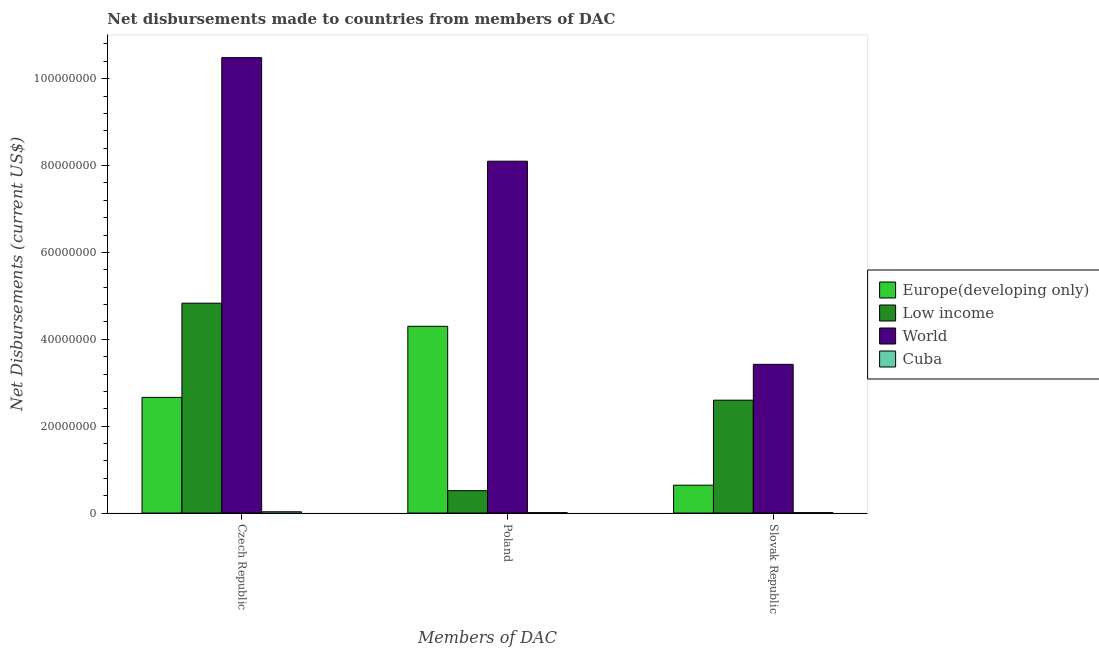How many bars are there on the 1st tick from the right?
Keep it short and to the point. 4. What is the label of the 1st group of bars from the left?
Make the answer very short. Czech Republic. What is the net disbursements made by slovak republic in Low income?
Offer a very short reply. 2.60e+07. Across all countries, what is the maximum net disbursements made by slovak republic?
Ensure brevity in your answer.  3.42e+07. Across all countries, what is the minimum net disbursements made by czech republic?
Offer a terse response. 2.90e+05. In which country was the net disbursements made by czech republic maximum?
Give a very brief answer. World. In which country was the net disbursements made by slovak republic minimum?
Your answer should be very brief. Cuba. What is the total net disbursements made by poland in the graph?
Keep it short and to the point. 1.29e+08. What is the difference between the net disbursements made by slovak republic in Europe(developing only) and that in World?
Offer a very short reply. -2.78e+07. What is the difference between the net disbursements made by poland in World and the net disbursements made by slovak republic in Low income?
Provide a succinct answer. 5.50e+07. What is the average net disbursements made by czech republic per country?
Offer a very short reply. 4.50e+07. What is the difference between the net disbursements made by poland and net disbursements made by czech republic in Europe(developing only)?
Make the answer very short. 1.64e+07. In how many countries, is the net disbursements made by poland greater than 56000000 US$?
Make the answer very short. 1. What is the ratio of the net disbursements made by czech republic in Low income to that in Cuba?
Keep it short and to the point. 166.59. What is the difference between the highest and the second highest net disbursements made by slovak republic?
Your answer should be compact. 8.25e+06. What is the difference between the highest and the lowest net disbursements made by slovak republic?
Make the answer very short. 3.41e+07. In how many countries, is the net disbursements made by poland greater than the average net disbursements made by poland taken over all countries?
Ensure brevity in your answer.  2. Is the sum of the net disbursements made by poland in Europe(developing only) and Low income greater than the maximum net disbursements made by slovak republic across all countries?
Your answer should be very brief. Yes. What does the 1st bar from the left in Poland represents?
Provide a succinct answer. Europe(developing only). What does the 1st bar from the right in Slovak Republic represents?
Your response must be concise. Cuba. How many bars are there?
Your response must be concise. 12. How many countries are there in the graph?
Your response must be concise. 4. Are the values on the major ticks of Y-axis written in scientific E-notation?
Your answer should be very brief. No. Does the graph contain any zero values?
Provide a succinct answer. No. Does the graph contain grids?
Your answer should be very brief. No. What is the title of the graph?
Your answer should be very brief. Net disbursements made to countries from members of DAC. Does "Belize" appear as one of the legend labels in the graph?
Make the answer very short. No. What is the label or title of the X-axis?
Make the answer very short. Members of DAC. What is the label or title of the Y-axis?
Make the answer very short. Net Disbursements (current US$). What is the Net Disbursements (current US$) of Europe(developing only) in Czech Republic?
Provide a succinct answer. 2.66e+07. What is the Net Disbursements (current US$) in Low income in Czech Republic?
Keep it short and to the point. 4.83e+07. What is the Net Disbursements (current US$) in World in Czech Republic?
Offer a terse response. 1.05e+08. What is the Net Disbursements (current US$) in Cuba in Czech Republic?
Your response must be concise. 2.90e+05. What is the Net Disbursements (current US$) of Europe(developing only) in Poland?
Offer a terse response. 4.30e+07. What is the Net Disbursements (current US$) of Low income in Poland?
Your answer should be compact. 5.15e+06. What is the Net Disbursements (current US$) in World in Poland?
Offer a very short reply. 8.10e+07. What is the Net Disbursements (current US$) of Cuba in Poland?
Offer a very short reply. 9.00e+04. What is the Net Disbursements (current US$) in Europe(developing only) in Slovak Republic?
Provide a succinct answer. 6.41e+06. What is the Net Disbursements (current US$) of Low income in Slovak Republic?
Your response must be concise. 2.60e+07. What is the Net Disbursements (current US$) of World in Slovak Republic?
Offer a terse response. 3.42e+07. Across all Members of DAC, what is the maximum Net Disbursements (current US$) of Europe(developing only)?
Provide a short and direct response. 4.30e+07. Across all Members of DAC, what is the maximum Net Disbursements (current US$) of Low income?
Give a very brief answer. 4.83e+07. Across all Members of DAC, what is the maximum Net Disbursements (current US$) in World?
Your response must be concise. 1.05e+08. Across all Members of DAC, what is the minimum Net Disbursements (current US$) in Europe(developing only)?
Provide a succinct answer. 6.41e+06. Across all Members of DAC, what is the minimum Net Disbursements (current US$) in Low income?
Provide a short and direct response. 5.15e+06. Across all Members of DAC, what is the minimum Net Disbursements (current US$) in World?
Ensure brevity in your answer.  3.42e+07. Across all Members of DAC, what is the minimum Net Disbursements (current US$) of Cuba?
Give a very brief answer. 9.00e+04. What is the total Net Disbursements (current US$) in Europe(developing only) in the graph?
Offer a very short reply. 7.60e+07. What is the total Net Disbursements (current US$) of Low income in the graph?
Offer a very short reply. 7.94e+07. What is the total Net Disbursements (current US$) in World in the graph?
Keep it short and to the point. 2.20e+08. What is the difference between the Net Disbursements (current US$) of Europe(developing only) in Czech Republic and that in Poland?
Offer a very short reply. -1.64e+07. What is the difference between the Net Disbursements (current US$) of Low income in Czech Republic and that in Poland?
Ensure brevity in your answer.  4.32e+07. What is the difference between the Net Disbursements (current US$) of World in Czech Republic and that in Poland?
Make the answer very short. 2.38e+07. What is the difference between the Net Disbursements (current US$) in Cuba in Czech Republic and that in Poland?
Your answer should be compact. 2.00e+05. What is the difference between the Net Disbursements (current US$) in Europe(developing only) in Czech Republic and that in Slovak Republic?
Give a very brief answer. 2.02e+07. What is the difference between the Net Disbursements (current US$) of Low income in Czech Republic and that in Slovak Republic?
Ensure brevity in your answer.  2.23e+07. What is the difference between the Net Disbursements (current US$) in World in Czech Republic and that in Slovak Republic?
Your response must be concise. 7.06e+07. What is the difference between the Net Disbursements (current US$) of Europe(developing only) in Poland and that in Slovak Republic?
Offer a very short reply. 3.66e+07. What is the difference between the Net Disbursements (current US$) of Low income in Poland and that in Slovak Republic?
Your answer should be compact. -2.08e+07. What is the difference between the Net Disbursements (current US$) of World in Poland and that in Slovak Republic?
Your answer should be very brief. 4.68e+07. What is the difference between the Net Disbursements (current US$) in Cuba in Poland and that in Slovak Republic?
Offer a terse response. 0. What is the difference between the Net Disbursements (current US$) of Europe(developing only) in Czech Republic and the Net Disbursements (current US$) of Low income in Poland?
Your response must be concise. 2.15e+07. What is the difference between the Net Disbursements (current US$) in Europe(developing only) in Czech Republic and the Net Disbursements (current US$) in World in Poland?
Give a very brief answer. -5.44e+07. What is the difference between the Net Disbursements (current US$) in Europe(developing only) in Czech Republic and the Net Disbursements (current US$) in Cuba in Poland?
Your answer should be compact. 2.65e+07. What is the difference between the Net Disbursements (current US$) of Low income in Czech Republic and the Net Disbursements (current US$) of World in Poland?
Make the answer very short. -3.27e+07. What is the difference between the Net Disbursements (current US$) of Low income in Czech Republic and the Net Disbursements (current US$) of Cuba in Poland?
Ensure brevity in your answer.  4.82e+07. What is the difference between the Net Disbursements (current US$) of World in Czech Republic and the Net Disbursements (current US$) of Cuba in Poland?
Offer a very short reply. 1.05e+08. What is the difference between the Net Disbursements (current US$) of Europe(developing only) in Czech Republic and the Net Disbursements (current US$) of Low income in Slovak Republic?
Ensure brevity in your answer.  6.40e+05. What is the difference between the Net Disbursements (current US$) in Europe(developing only) in Czech Republic and the Net Disbursements (current US$) in World in Slovak Republic?
Provide a succinct answer. -7.61e+06. What is the difference between the Net Disbursements (current US$) of Europe(developing only) in Czech Republic and the Net Disbursements (current US$) of Cuba in Slovak Republic?
Your answer should be very brief. 2.65e+07. What is the difference between the Net Disbursements (current US$) in Low income in Czech Republic and the Net Disbursements (current US$) in World in Slovak Republic?
Your answer should be compact. 1.41e+07. What is the difference between the Net Disbursements (current US$) in Low income in Czech Republic and the Net Disbursements (current US$) in Cuba in Slovak Republic?
Provide a short and direct response. 4.82e+07. What is the difference between the Net Disbursements (current US$) in World in Czech Republic and the Net Disbursements (current US$) in Cuba in Slovak Republic?
Offer a terse response. 1.05e+08. What is the difference between the Net Disbursements (current US$) in Europe(developing only) in Poland and the Net Disbursements (current US$) in Low income in Slovak Republic?
Provide a succinct answer. 1.70e+07. What is the difference between the Net Disbursements (current US$) in Europe(developing only) in Poland and the Net Disbursements (current US$) in World in Slovak Republic?
Provide a succinct answer. 8.76e+06. What is the difference between the Net Disbursements (current US$) of Europe(developing only) in Poland and the Net Disbursements (current US$) of Cuba in Slovak Republic?
Ensure brevity in your answer.  4.29e+07. What is the difference between the Net Disbursements (current US$) in Low income in Poland and the Net Disbursements (current US$) in World in Slovak Republic?
Provide a short and direct response. -2.91e+07. What is the difference between the Net Disbursements (current US$) of Low income in Poland and the Net Disbursements (current US$) of Cuba in Slovak Republic?
Your answer should be very brief. 5.06e+06. What is the difference between the Net Disbursements (current US$) of World in Poland and the Net Disbursements (current US$) of Cuba in Slovak Republic?
Your response must be concise. 8.09e+07. What is the average Net Disbursements (current US$) of Europe(developing only) per Members of DAC?
Give a very brief answer. 2.53e+07. What is the average Net Disbursements (current US$) of Low income per Members of DAC?
Your answer should be compact. 2.65e+07. What is the average Net Disbursements (current US$) in World per Members of DAC?
Make the answer very short. 7.34e+07. What is the average Net Disbursements (current US$) in Cuba per Members of DAC?
Your answer should be very brief. 1.57e+05. What is the difference between the Net Disbursements (current US$) of Europe(developing only) and Net Disbursements (current US$) of Low income in Czech Republic?
Your answer should be very brief. -2.17e+07. What is the difference between the Net Disbursements (current US$) in Europe(developing only) and Net Disbursements (current US$) in World in Czech Republic?
Offer a very short reply. -7.82e+07. What is the difference between the Net Disbursements (current US$) of Europe(developing only) and Net Disbursements (current US$) of Cuba in Czech Republic?
Offer a terse response. 2.63e+07. What is the difference between the Net Disbursements (current US$) in Low income and Net Disbursements (current US$) in World in Czech Republic?
Your answer should be compact. -5.65e+07. What is the difference between the Net Disbursements (current US$) of Low income and Net Disbursements (current US$) of Cuba in Czech Republic?
Offer a very short reply. 4.80e+07. What is the difference between the Net Disbursements (current US$) in World and Net Disbursements (current US$) in Cuba in Czech Republic?
Make the answer very short. 1.05e+08. What is the difference between the Net Disbursements (current US$) in Europe(developing only) and Net Disbursements (current US$) in Low income in Poland?
Your answer should be compact. 3.78e+07. What is the difference between the Net Disbursements (current US$) of Europe(developing only) and Net Disbursements (current US$) of World in Poland?
Offer a very short reply. -3.80e+07. What is the difference between the Net Disbursements (current US$) of Europe(developing only) and Net Disbursements (current US$) of Cuba in Poland?
Ensure brevity in your answer.  4.29e+07. What is the difference between the Net Disbursements (current US$) in Low income and Net Disbursements (current US$) in World in Poland?
Your response must be concise. -7.58e+07. What is the difference between the Net Disbursements (current US$) of Low income and Net Disbursements (current US$) of Cuba in Poland?
Your response must be concise. 5.06e+06. What is the difference between the Net Disbursements (current US$) in World and Net Disbursements (current US$) in Cuba in Poland?
Your answer should be very brief. 8.09e+07. What is the difference between the Net Disbursements (current US$) in Europe(developing only) and Net Disbursements (current US$) in Low income in Slovak Republic?
Your answer should be very brief. -1.96e+07. What is the difference between the Net Disbursements (current US$) of Europe(developing only) and Net Disbursements (current US$) of World in Slovak Republic?
Provide a succinct answer. -2.78e+07. What is the difference between the Net Disbursements (current US$) in Europe(developing only) and Net Disbursements (current US$) in Cuba in Slovak Republic?
Your response must be concise. 6.32e+06. What is the difference between the Net Disbursements (current US$) in Low income and Net Disbursements (current US$) in World in Slovak Republic?
Your answer should be very brief. -8.25e+06. What is the difference between the Net Disbursements (current US$) of Low income and Net Disbursements (current US$) of Cuba in Slovak Republic?
Give a very brief answer. 2.59e+07. What is the difference between the Net Disbursements (current US$) in World and Net Disbursements (current US$) in Cuba in Slovak Republic?
Give a very brief answer. 3.41e+07. What is the ratio of the Net Disbursements (current US$) of Europe(developing only) in Czech Republic to that in Poland?
Provide a succinct answer. 0.62. What is the ratio of the Net Disbursements (current US$) in Low income in Czech Republic to that in Poland?
Offer a terse response. 9.38. What is the ratio of the Net Disbursements (current US$) in World in Czech Republic to that in Poland?
Your answer should be very brief. 1.29. What is the ratio of the Net Disbursements (current US$) of Cuba in Czech Republic to that in Poland?
Make the answer very short. 3.22. What is the ratio of the Net Disbursements (current US$) in Europe(developing only) in Czech Republic to that in Slovak Republic?
Your response must be concise. 4.15. What is the ratio of the Net Disbursements (current US$) of Low income in Czech Republic to that in Slovak Republic?
Offer a terse response. 1.86. What is the ratio of the Net Disbursements (current US$) in World in Czech Republic to that in Slovak Republic?
Provide a short and direct response. 3.06. What is the ratio of the Net Disbursements (current US$) of Cuba in Czech Republic to that in Slovak Republic?
Ensure brevity in your answer.  3.22. What is the ratio of the Net Disbursements (current US$) in Europe(developing only) in Poland to that in Slovak Republic?
Make the answer very short. 6.71. What is the ratio of the Net Disbursements (current US$) in Low income in Poland to that in Slovak Republic?
Your answer should be very brief. 0.2. What is the ratio of the Net Disbursements (current US$) in World in Poland to that in Slovak Republic?
Ensure brevity in your answer.  2.37. What is the difference between the highest and the second highest Net Disbursements (current US$) of Europe(developing only)?
Keep it short and to the point. 1.64e+07. What is the difference between the highest and the second highest Net Disbursements (current US$) in Low income?
Keep it short and to the point. 2.23e+07. What is the difference between the highest and the second highest Net Disbursements (current US$) of World?
Provide a succinct answer. 2.38e+07. What is the difference between the highest and the second highest Net Disbursements (current US$) of Cuba?
Your response must be concise. 2.00e+05. What is the difference between the highest and the lowest Net Disbursements (current US$) of Europe(developing only)?
Keep it short and to the point. 3.66e+07. What is the difference between the highest and the lowest Net Disbursements (current US$) of Low income?
Provide a succinct answer. 4.32e+07. What is the difference between the highest and the lowest Net Disbursements (current US$) in World?
Offer a terse response. 7.06e+07. What is the difference between the highest and the lowest Net Disbursements (current US$) in Cuba?
Offer a very short reply. 2.00e+05. 